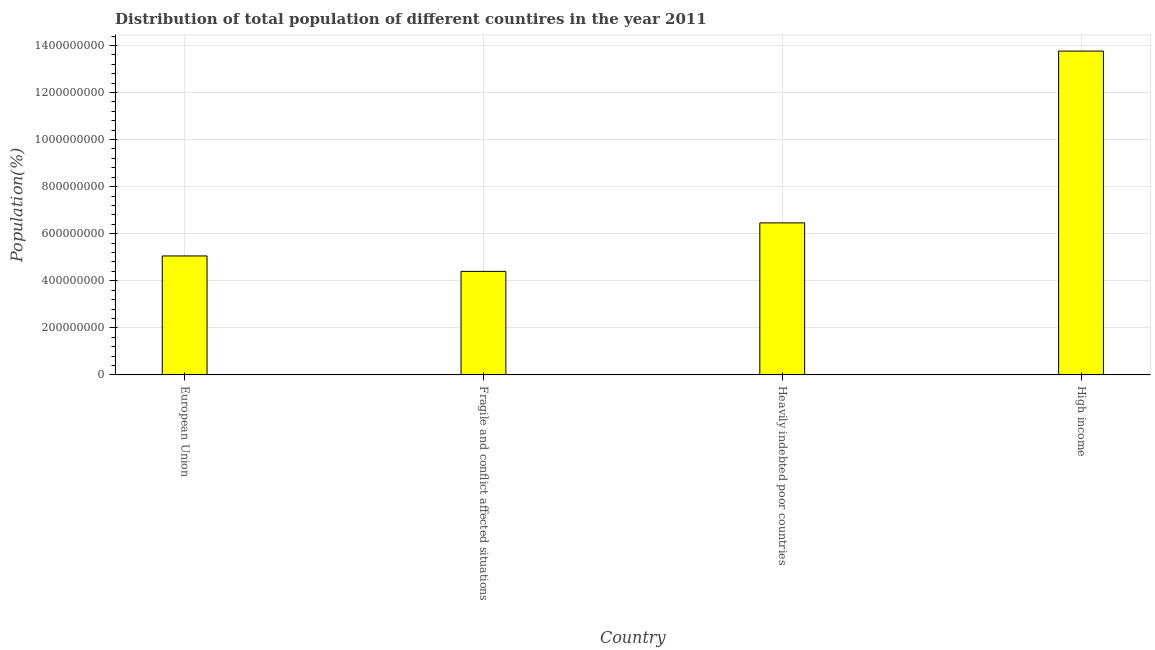What is the title of the graph?
Your response must be concise. Distribution of total population of different countires in the year 2011. What is the label or title of the X-axis?
Your response must be concise. Country. What is the label or title of the Y-axis?
Your answer should be very brief. Population(%). What is the population in Fragile and conflict affected situations?
Your answer should be compact. 4.40e+08. Across all countries, what is the maximum population?
Provide a succinct answer. 1.38e+09. Across all countries, what is the minimum population?
Give a very brief answer. 4.40e+08. In which country was the population maximum?
Your answer should be compact. High income. In which country was the population minimum?
Ensure brevity in your answer.  Fragile and conflict affected situations. What is the sum of the population?
Keep it short and to the point. 2.97e+09. What is the difference between the population in Fragile and conflict affected situations and High income?
Your answer should be compact. -9.36e+08. What is the average population per country?
Your response must be concise. 7.42e+08. What is the median population?
Make the answer very short. 5.76e+08. In how many countries, is the population greater than 880000000 %?
Your answer should be compact. 1. What is the ratio of the population in European Union to that in Heavily indebted poor countries?
Your answer should be very brief. 0.78. Is the population in Heavily indebted poor countries less than that in High income?
Your response must be concise. Yes. What is the difference between the highest and the second highest population?
Provide a succinct answer. 7.30e+08. What is the difference between the highest and the lowest population?
Your answer should be compact. 9.36e+08. In how many countries, is the population greater than the average population taken over all countries?
Offer a very short reply. 1. Are all the bars in the graph horizontal?
Ensure brevity in your answer.  No. What is the Population(%) of European Union?
Ensure brevity in your answer.  5.06e+08. What is the Population(%) in Fragile and conflict affected situations?
Make the answer very short. 4.40e+08. What is the Population(%) of Heavily indebted poor countries?
Make the answer very short. 6.46e+08. What is the Population(%) in High income?
Offer a very short reply. 1.38e+09. What is the difference between the Population(%) in European Union and Fragile and conflict affected situations?
Your answer should be very brief. 6.56e+07. What is the difference between the Population(%) in European Union and Heavily indebted poor countries?
Make the answer very short. -1.40e+08. What is the difference between the Population(%) in European Union and High income?
Your answer should be compact. -8.71e+08. What is the difference between the Population(%) in Fragile and conflict affected situations and Heavily indebted poor countries?
Your answer should be compact. -2.06e+08. What is the difference between the Population(%) in Fragile and conflict affected situations and High income?
Keep it short and to the point. -9.36e+08. What is the difference between the Population(%) in Heavily indebted poor countries and High income?
Offer a very short reply. -7.30e+08. What is the ratio of the Population(%) in European Union to that in Fragile and conflict affected situations?
Keep it short and to the point. 1.15. What is the ratio of the Population(%) in European Union to that in Heavily indebted poor countries?
Ensure brevity in your answer.  0.78. What is the ratio of the Population(%) in European Union to that in High income?
Give a very brief answer. 0.37. What is the ratio of the Population(%) in Fragile and conflict affected situations to that in Heavily indebted poor countries?
Ensure brevity in your answer.  0.68. What is the ratio of the Population(%) in Fragile and conflict affected situations to that in High income?
Offer a terse response. 0.32. What is the ratio of the Population(%) in Heavily indebted poor countries to that in High income?
Keep it short and to the point. 0.47. 